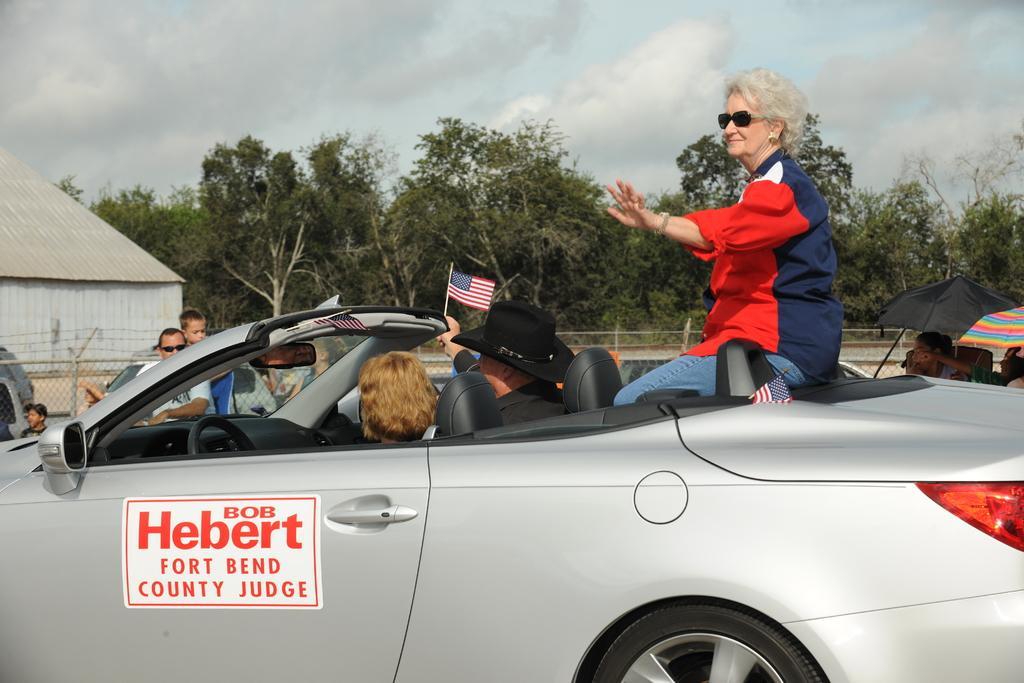How would you summarize this image in a sentence or two? It is roadshow there is a grey color car three people are sitting in the car t,here also flags of United States of America in the car, beside the car there are some other people who are watching them ,in the background there are trees, a shed, sky and clouds. 